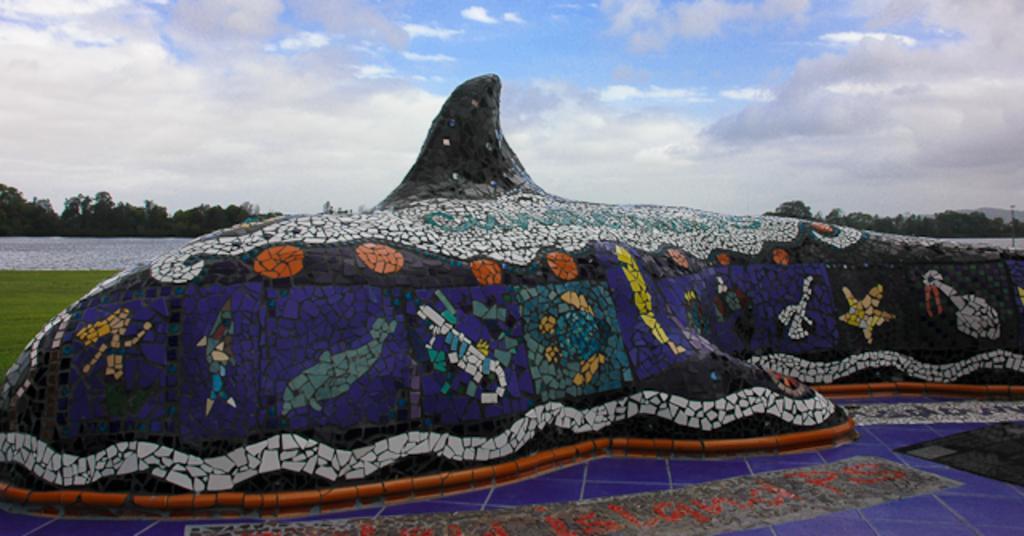Describe this image in one or two sentences. In this image there is a whale statue which is made up of tiles. At the bottom there is a floor on which there are tiles. At the top there is the sky. In the background there is water. Beside the water there are trees. 